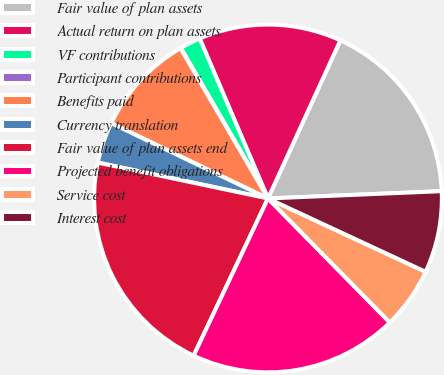<chart> <loc_0><loc_0><loc_500><loc_500><pie_chart><fcel>Fair value of plan assets<fcel>Actual return on plan assets<fcel>VF contributions<fcel>Participant contributions<fcel>Benefits paid<fcel>Currency translation<fcel>Fair value of plan assets end<fcel>Projected benefit obligations<fcel>Service cost<fcel>Interest cost<nl><fcel>17.5%<fcel>13.26%<fcel>1.93%<fcel>0.04%<fcel>9.48%<fcel>3.82%<fcel>21.28%<fcel>19.39%<fcel>5.71%<fcel>7.6%<nl></chart> 